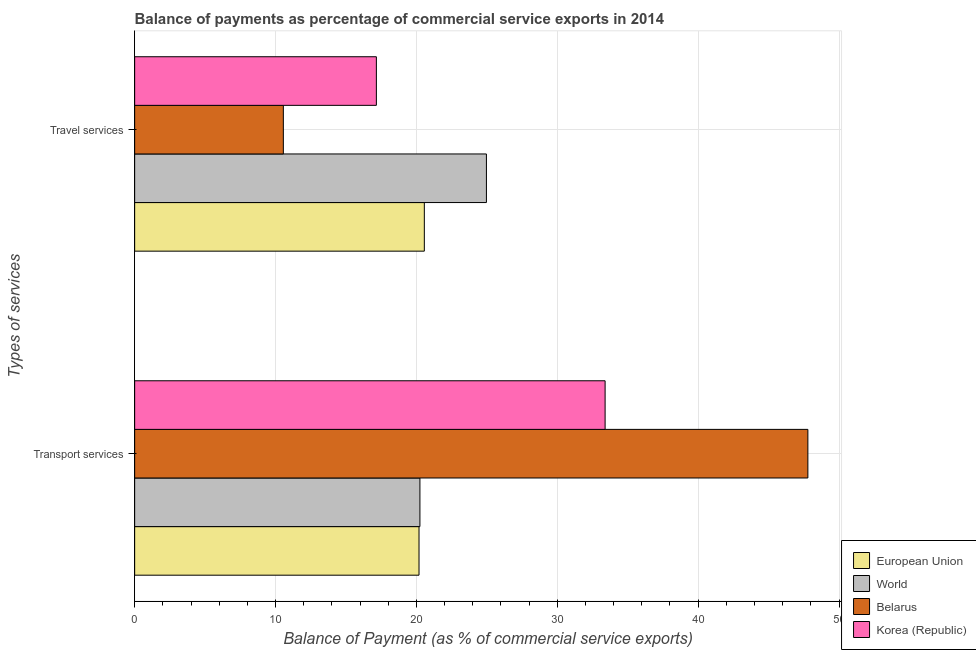How many groups of bars are there?
Provide a succinct answer. 2. Are the number of bars per tick equal to the number of legend labels?
Your response must be concise. Yes. What is the label of the 2nd group of bars from the top?
Provide a succinct answer. Transport services. What is the balance of payments of transport services in Belarus?
Your answer should be very brief. 47.79. Across all countries, what is the maximum balance of payments of travel services?
Your answer should be very brief. 24.97. Across all countries, what is the minimum balance of payments of travel services?
Make the answer very short. 10.56. In which country was the balance of payments of travel services maximum?
Keep it short and to the point. World. What is the total balance of payments of travel services in the graph?
Keep it short and to the point. 73.25. What is the difference between the balance of payments of travel services in World and that in Belarus?
Your answer should be very brief. 14.41. What is the difference between the balance of payments of travel services in World and the balance of payments of transport services in Belarus?
Give a very brief answer. -22.82. What is the average balance of payments of travel services per country?
Your response must be concise. 18.31. What is the difference between the balance of payments of transport services and balance of payments of travel services in World?
Offer a very short reply. -4.72. In how many countries, is the balance of payments of travel services greater than 30 %?
Your answer should be compact. 0. What is the ratio of the balance of payments of travel services in Korea (Republic) to that in Belarus?
Give a very brief answer. 1.63. Is the balance of payments of travel services in World less than that in European Union?
Provide a succinct answer. No. In how many countries, is the balance of payments of transport services greater than the average balance of payments of transport services taken over all countries?
Offer a very short reply. 2. What does the 3rd bar from the bottom in Transport services represents?
Ensure brevity in your answer.  Belarus. Are the values on the major ticks of X-axis written in scientific E-notation?
Make the answer very short. No. Does the graph contain any zero values?
Give a very brief answer. No. Does the graph contain grids?
Ensure brevity in your answer.  Yes. How are the legend labels stacked?
Provide a succinct answer. Vertical. What is the title of the graph?
Your response must be concise. Balance of payments as percentage of commercial service exports in 2014. What is the label or title of the X-axis?
Your answer should be very brief. Balance of Payment (as % of commercial service exports). What is the label or title of the Y-axis?
Your answer should be compact. Types of services. What is the Balance of Payment (as % of commercial service exports) of European Union in Transport services?
Your answer should be very brief. 20.19. What is the Balance of Payment (as % of commercial service exports) in World in Transport services?
Provide a short and direct response. 20.25. What is the Balance of Payment (as % of commercial service exports) of Belarus in Transport services?
Make the answer very short. 47.79. What is the Balance of Payment (as % of commercial service exports) of Korea (Republic) in Transport services?
Provide a short and direct response. 33.39. What is the Balance of Payment (as % of commercial service exports) of European Union in Travel services?
Give a very brief answer. 20.56. What is the Balance of Payment (as % of commercial service exports) in World in Travel services?
Your response must be concise. 24.97. What is the Balance of Payment (as % of commercial service exports) of Belarus in Travel services?
Offer a very short reply. 10.56. What is the Balance of Payment (as % of commercial service exports) of Korea (Republic) in Travel services?
Provide a succinct answer. 17.16. Across all Types of services, what is the maximum Balance of Payment (as % of commercial service exports) of European Union?
Offer a very short reply. 20.56. Across all Types of services, what is the maximum Balance of Payment (as % of commercial service exports) in World?
Make the answer very short. 24.97. Across all Types of services, what is the maximum Balance of Payment (as % of commercial service exports) of Belarus?
Your response must be concise. 47.79. Across all Types of services, what is the maximum Balance of Payment (as % of commercial service exports) in Korea (Republic)?
Ensure brevity in your answer.  33.39. Across all Types of services, what is the minimum Balance of Payment (as % of commercial service exports) in European Union?
Ensure brevity in your answer.  20.19. Across all Types of services, what is the minimum Balance of Payment (as % of commercial service exports) of World?
Ensure brevity in your answer.  20.25. Across all Types of services, what is the minimum Balance of Payment (as % of commercial service exports) of Belarus?
Provide a succinct answer. 10.56. Across all Types of services, what is the minimum Balance of Payment (as % of commercial service exports) in Korea (Republic)?
Provide a short and direct response. 17.16. What is the total Balance of Payment (as % of commercial service exports) of European Union in the graph?
Offer a very short reply. 40.75. What is the total Balance of Payment (as % of commercial service exports) in World in the graph?
Keep it short and to the point. 45.22. What is the total Balance of Payment (as % of commercial service exports) of Belarus in the graph?
Provide a short and direct response. 58.34. What is the total Balance of Payment (as % of commercial service exports) of Korea (Republic) in the graph?
Your response must be concise. 50.55. What is the difference between the Balance of Payment (as % of commercial service exports) of European Union in Transport services and that in Travel services?
Keep it short and to the point. -0.38. What is the difference between the Balance of Payment (as % of commercial service exports) in World in Transport services and that in Travel services?
Offer a very short reply. -4.72. What is the difference between the Balance of Payment (as % of commercial service exports) of Belarus in Transport services and that in Travel services?
Provide a succinct answer. 37.23. What is the difference between the Balance of Payment (as % of commercial service exports) of Korea (Republic) in Transport services and that in Travel services?
Offer a terse response. 16.24. What is the difference between the Balance of Payment (as % of commercial service exports) of European Union in Transport services and the Balance of Payment (as % of commercial service exports) of World in Travel services?
Your answer should be very brief. -4.78. What is the difference between the Balance of Payment (as % of commercial service exports) of European Union in Transport services and the Balance of Payment (as % of commercial service exports) of Belarus in Travel services?
Keep it short and to the point. 9.63. What is the difference between the Balance of Payment (as % of commercial service exports) in European Union in Transport services and the Balance of Payment (as % of commercial service exports) in Korea (Republic) in Travel services?
Keep it short and to the point. 3.03. What is the difference between the Balance of Payment (as % of commercial service exports) in World in Transport services and the Balance of Payment (as % of commercial service exports) in Belarus in Travel services?
Offer a very short reply. 9.69. What is the difference between the Balance of Payment (as % of commercial service exports) in World in Transport services and the Balance of Payment (as % of commercial service exports) in Korea (Republic) in Travel services?
Give a very brief answer. 3.09. What is the difference between the Balance of Payment (as % of commercial service exports) of Belarus in Transport services and the Balance of Payment (as % of commercial service exports) of Korea (Republic) in Travel services?
Make the answer very short. 30.63. What is the average Balance of Payment (as % of commercial service exports) in European Union per Types of services?
Offer a terse response. 20.37. What is the average Balance of Payment (as % of commercial service exports) in World per Types of services?
Offer a very short reply. 22.61. What is the average Balance of Payment (as % of commercial service exports) of Belarus per Types of services?
Ensure brevity in your answer.  29.17. What is the average Balance of Payment (as % of commercial service exports) in Korea (Republic) per Types of services?
Keep it short and to the point. 25.28. What is the difference between the Balance of Payment (as % of commercial service exports) of European Union and Balance of Payment (as % of commercial service exports) of World in Transport services?
Your answer should be very brief. -0.06. What is the difference between the Balance of Payment (as % of commercial service exports) of European Union and Balance of Payment (as % of commercial service exports) of Belarus in Transport services?
Offer a terse response. -27.6. What is the difference between the Balance of Payment (as % of commercial service exports) of European Union and Balance of Payment (as % of commercial service exports) of Korea (Republic) in Transport services?
Your answer should be compact. -13.21. What is the difference between the Balance of Payment (as % of commercial service exports) in World and Balance of Payment (as % of commercial service exports) in Belarus in Transport services?
Provide a short and direct response. -27.54. What is the difference between the Balance of Payment (as % of commercial service exports) in World and Balance of Payment (as % of commercial service exports) in Korea (Republic) in Transport services?
Provide a succinct answer. -13.15. What is the difference between the Balance of Payment (as % of commercial service exports) of Belarus and Balance of Payment (as % of commercial service exports) of Korea (Republic) in Transport services?
Provide a succinct answer. 14.39. What is the difference between the Balance of Payment (as % of commercial service exports) in European Union and Balance of Payment (as % of commercial service exports) in World in Travel services?
Provide a succinct answer. -4.41. What is the difference between the Balance of Payment (as % of commercial service exports) in European Union and Balance of Payment (as % of commercial service exports) in Belarus in Travel services?
Your response must be concise. 10.01. What is the difference between the Balance of Payment (as % of commercial service exports) of European Union and Balance of Payment (as % of commercial service exports) of Korea (Republic) in Travel services?
Give a very brief answer. 3.4. What is the difference between the Balance of Payment (as % of commercial service exports) in World and Balance of Payment (as % of commercial service exports) in Belarus in Travel services?
Offer a terse response. 14.41. What is the difference between the Balance of Payment (as % of commercial service exports) of World and Balance of Payment (as % of commercial service exports) of Korea (Republic) in Travel services?
Ensure brevity in your answer.  7.81. What is the difference between the Balance of Payment (as % of commercial service exports) in Belarus and Balance of Payment (as % of commercial service exports) in Korea (Republic) in Travel services?
Your answer should be compact. -6.6. What is the ratio of the Balance of Payment (as % of commercial service exports) in European Union in Transport services to that in Travel services?
Offer a terse response. 0.98. What is the ratio of the Balance of Payment (as % of commercial service exports) of World in Transport services to that in Travel services?
Provide a short and direct response. 0.81. What is the ratio of the Balance of Payment (as % of commercial service exports) in Belarus in Transport services to that in Travel services?
Ensure brevity in your answer.  4.53. What is the ratio of the Balance of Payment (as % of commercial service exports) of Korea (Republic) in Transport services to that in Travel services?
Your response must be concise. 1.95. What is the difference between the highest and the second highest Balance of Payment (as % of commercial service exports) of European Union?
Offer a terse response. 0.38. What is the difference between the highest and the second highest Balance of Payment (as % of commercial service exports) of World?
Ensure brevity in your answer.  4.72. What is the difference between the highest and the second highest Balance of Payment (as % of commercial service exports) of Belarus?
Make the answer very short. 37.23. What is the difference between the highest and the second highest Balance of Payment (as % of commercial service exports) in Korea (Republic)?
Make the answer very short. 16.24. What is the difference between the highest and the lowest Balance of Payment (as % of commercial service exports) of European Union?
Give a very brief answer. 0.38. What is the difference between the highest and the lowest Balance of Payment (as % of commercial service exports) of World?
Offer a terse response. 4.72. What is the difference between the highest and the lowest Balance of Payment (as % of commercial service exports) in Belarus?
Keep it short and to the point. 37.23. What is the difference between the highest and the lowest Balance of Payment (as % of commercial service exports) of Korea (Republic)?
Your response must be concise. 16.24. 